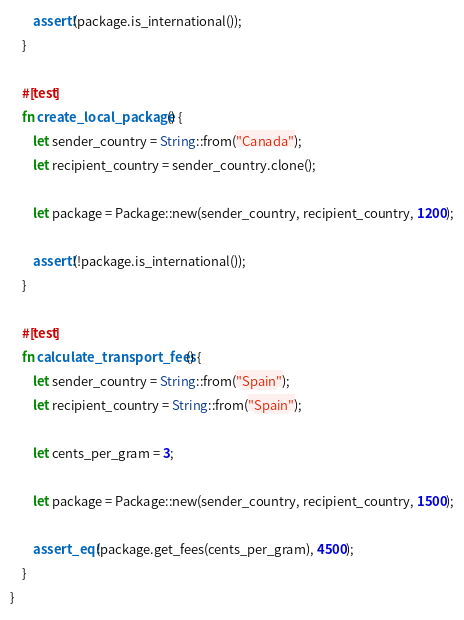<code> <loc_0><loc_0><loc_500><loc_500><_Rust_>
        assert!(package.is_international());
    }

    #[test]
    fn create_local_package() {
        let sender_country = String::from("Canada");
        let recipient_country = sender_country.clone();

        let package = Package::new(sender_country, recipient_country, 1200);

        assert!(!package.is_international());
    }

    #[test]
    fn calculate_transport_fees() {
        let sender_country = String::from("Spain");
        let recipient_country = String::from("Spain");

        let cents_per_gram = 3;

        let package = Package::new(sender_country, recipient_country, 1500);

        assert_eq!(package.get_fees(cents_per_gram), 4500);
    }
}
</code> 